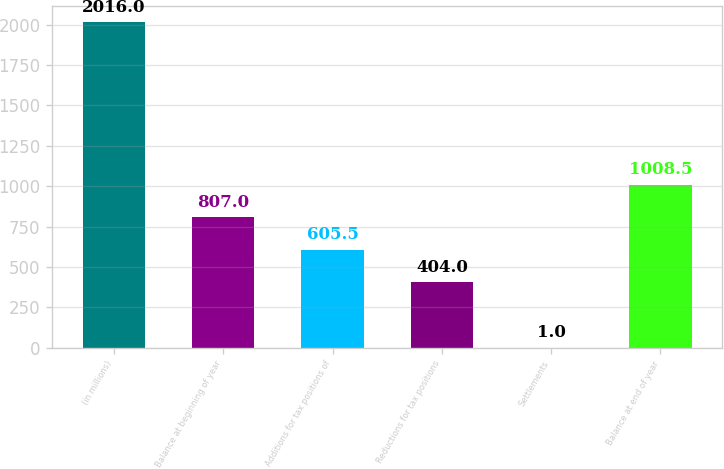<chart> <loc_0><loc_0><loc_500><loc_500><bar_chart><fcel>(in millions)<fcel>Balance at beginning of year<fcel>Additions for tax positions of<fcel>Reductions for tax positions<fcel>Settlements<fcel>Balance at end of year<nl><fcel>2016<fcel>807<fcel>605.5<fcel>404<fcel>1<fcel>1008.5<nl></chart> 